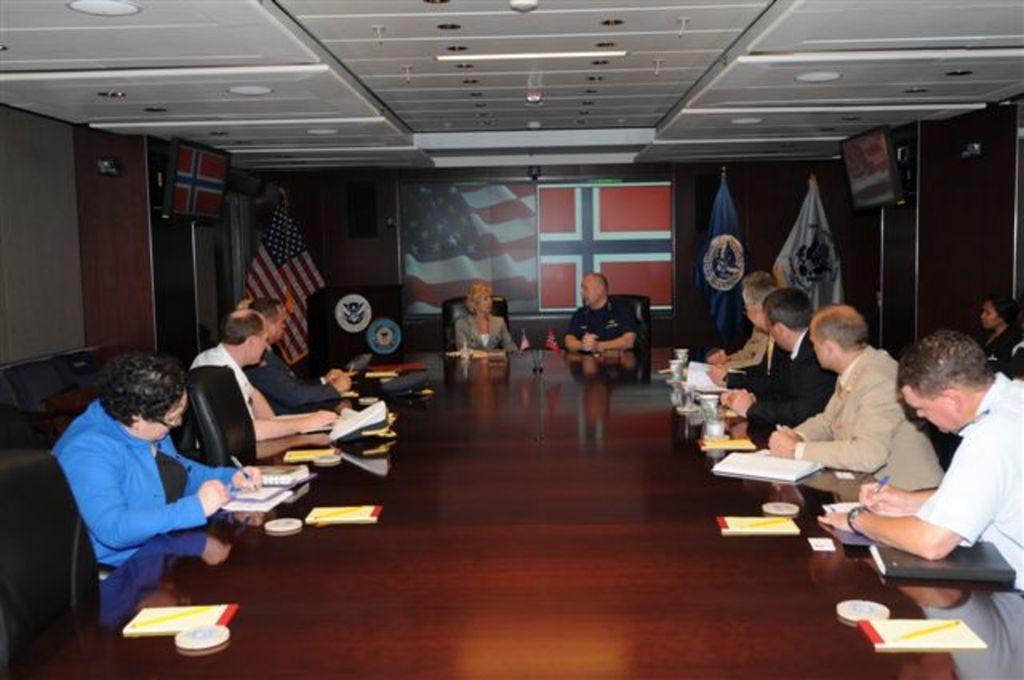In one or two sentences, can you explain what this image depicts? In this picture there are few people sitting on the chair in front of the table in that table we can see some books and glasses back side we can see the display a of flag the left corner we can see the real flag are placed and the right corner we can see the two more flats 